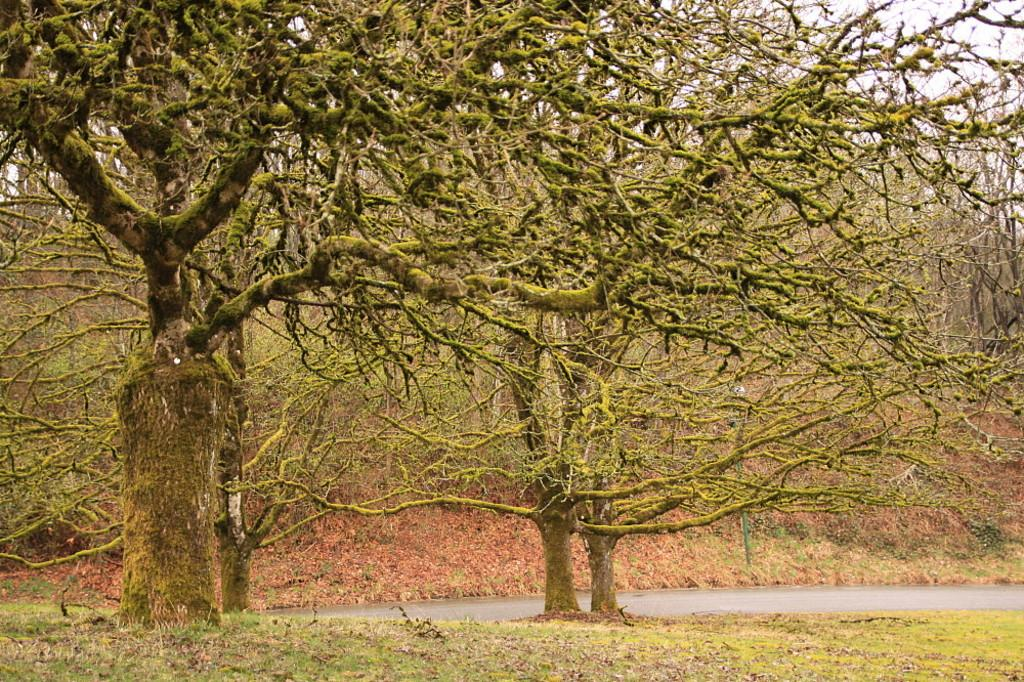What type of vegetation can be seen in the image? There are trees in the image. What is visible at the bottom of the image? There is water and ground visible at the bottom of the image. What type of utensil is being used to stir the water in the image? There is no utensil visible in the image, and the water is not being stirred. 